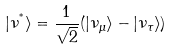Convert formula to latex. <formula><loc_0><loc_0><loc_500><loc_500>| \nu ^ { ^ { * } } \rangle = \frac { 1 } { \sqrt { 2 } } ( | \nu _ { \mu } \rangle - | \nu _ { \tau } \rangle )</formula> 